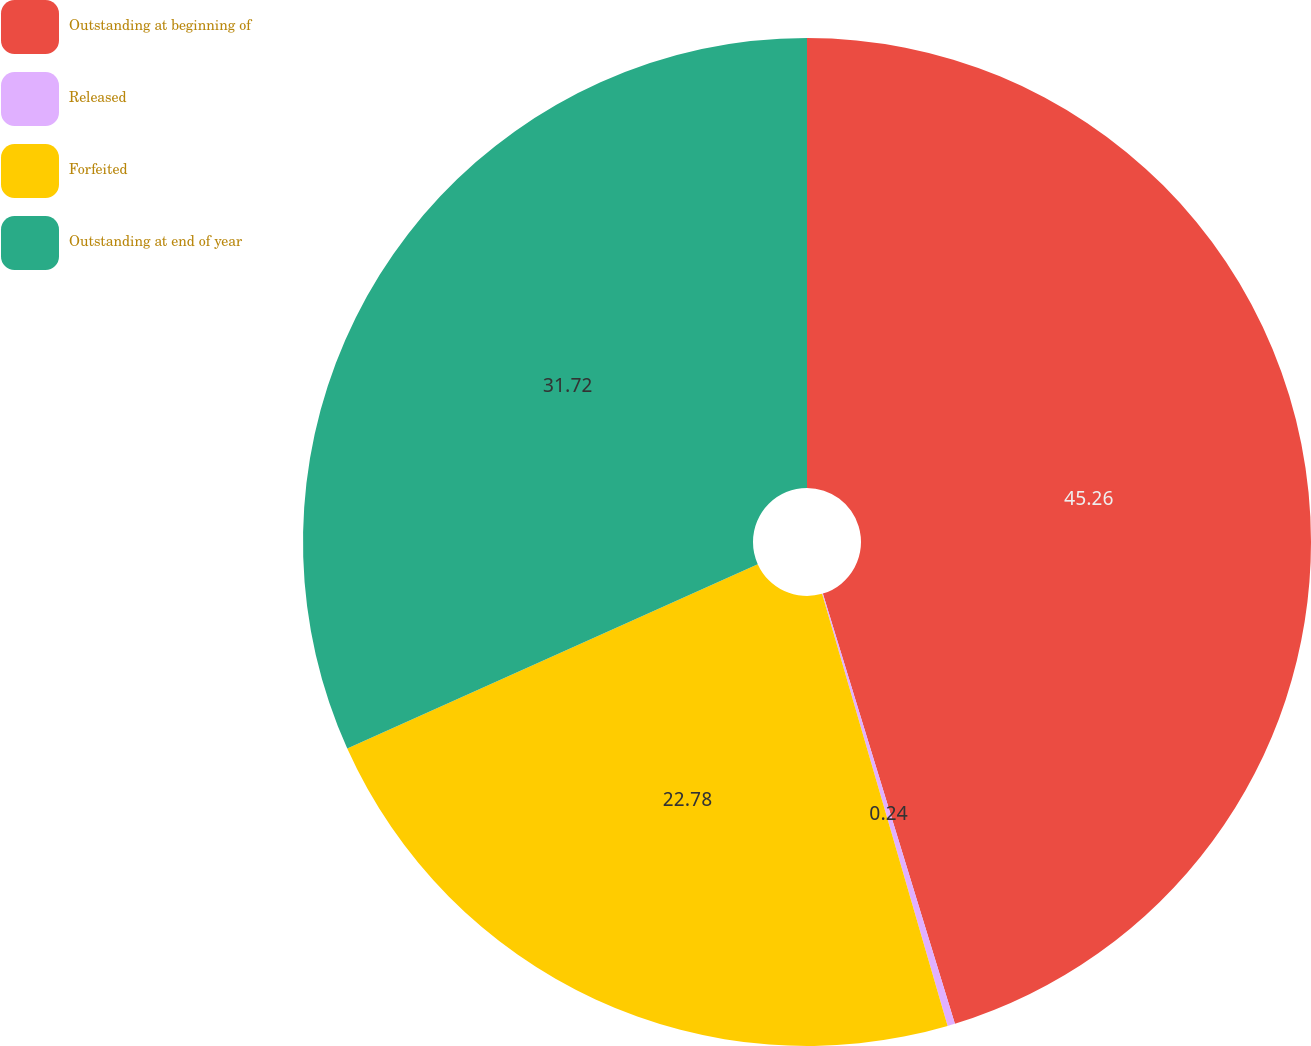Convert chart to OTSL. <chart><loc_0><loc_0><loc_500><loc_500><pie_chart><fcel>Outstanding at beginning of<fcel>Released<fcel>Forfeited<fcel>Outstanding at end of year<nl><fcel>45.26%<fcel>0.24%<fcel>22.78%<fcel>31.72%<nl></chart> 